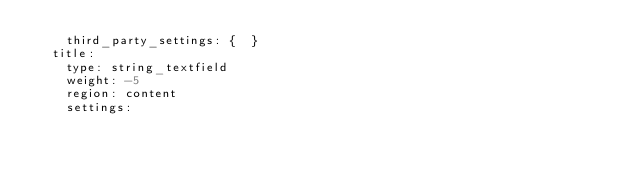Convert code to text. <code><loc_0><loc_0><loc_500><loc_500><_YAML_>    third_party_settings: {  }
  title:
    type: string_textfield
    weight: -5
    region: content
    settings:</code> 